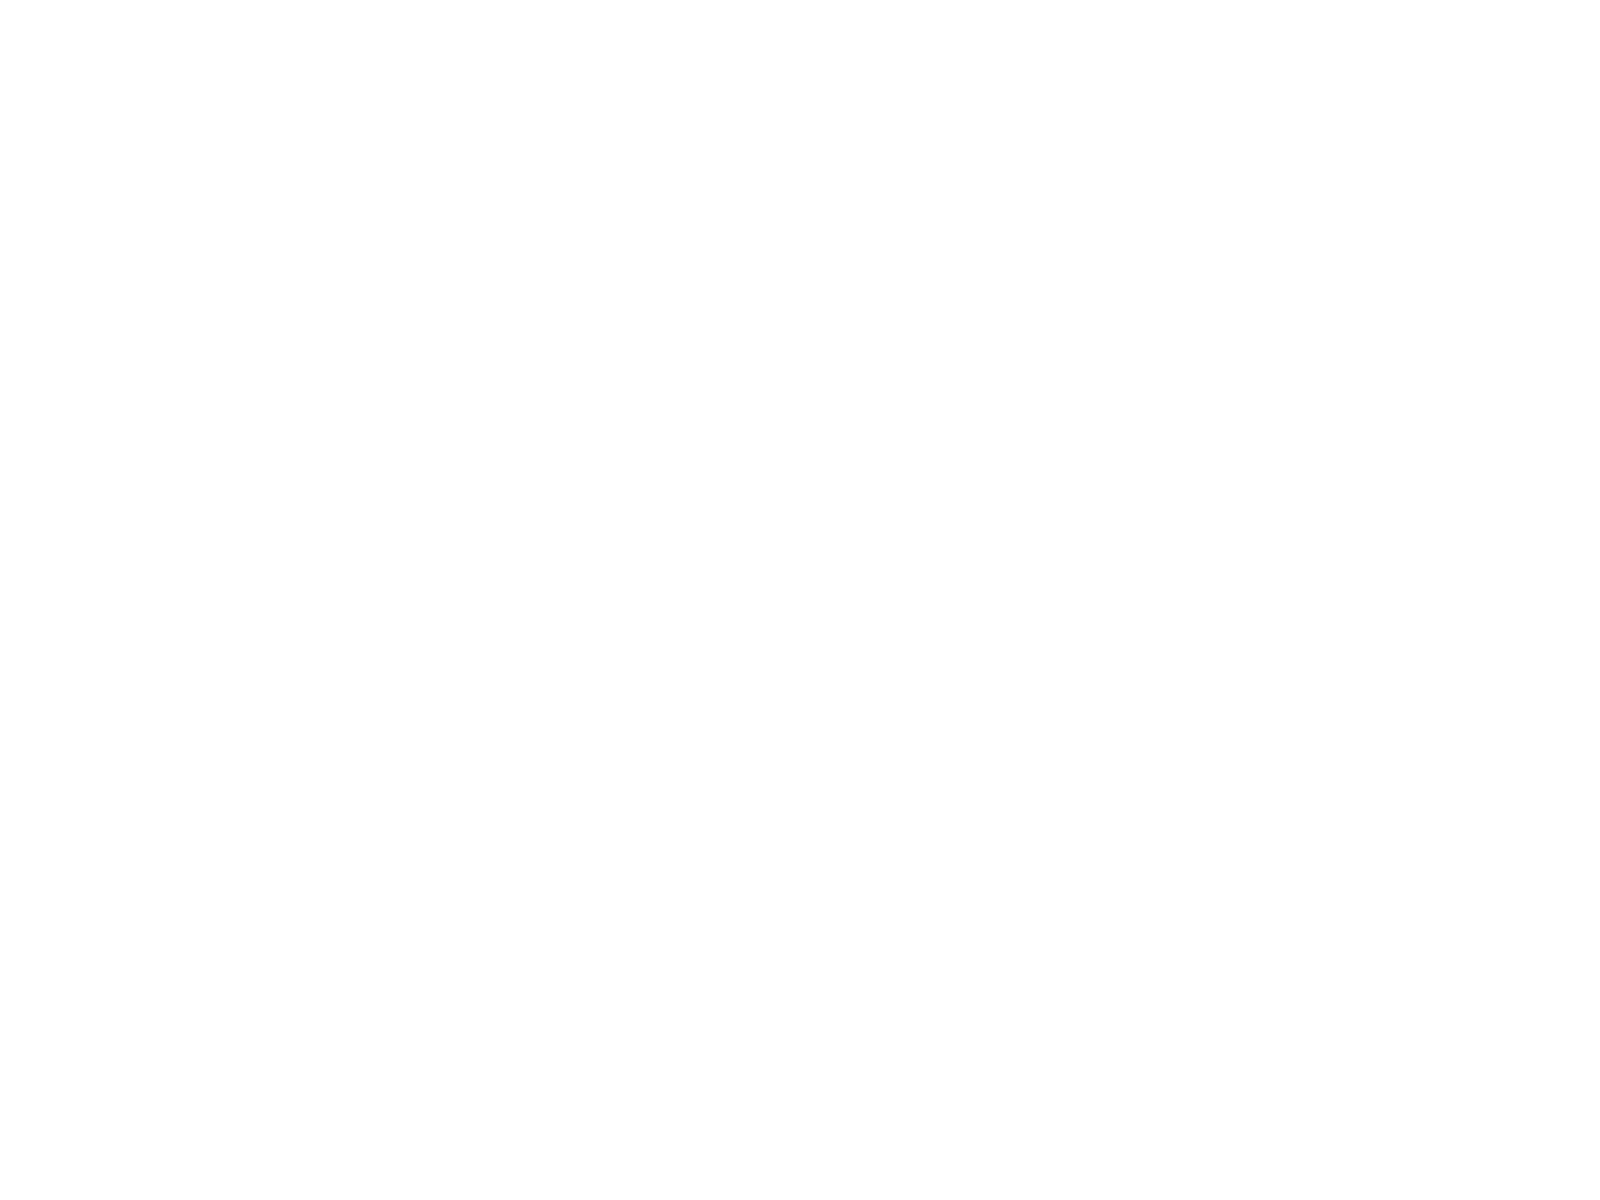Convert chart to OTSL. <chart><loc_0><loc_0><loc_500><loc_500><pie_chart><fcel>Payroll and benefits<fcel>Income and other tax accruals<fcel>Other<nl><fcel>58.7%<fcel>13.48%<fcel>27.82%<nl></chart> 